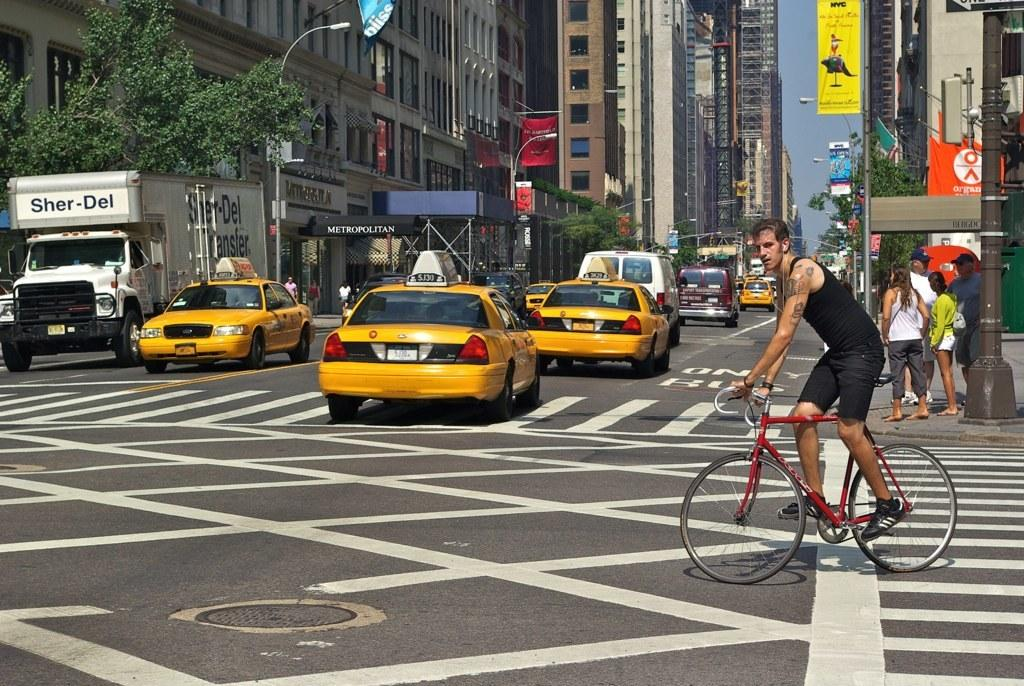<image>
Give a short and clear explanation of the subsequent image. A cyclist is crossing a busy street filled with taxis and a white truck that says Sher-Del. 